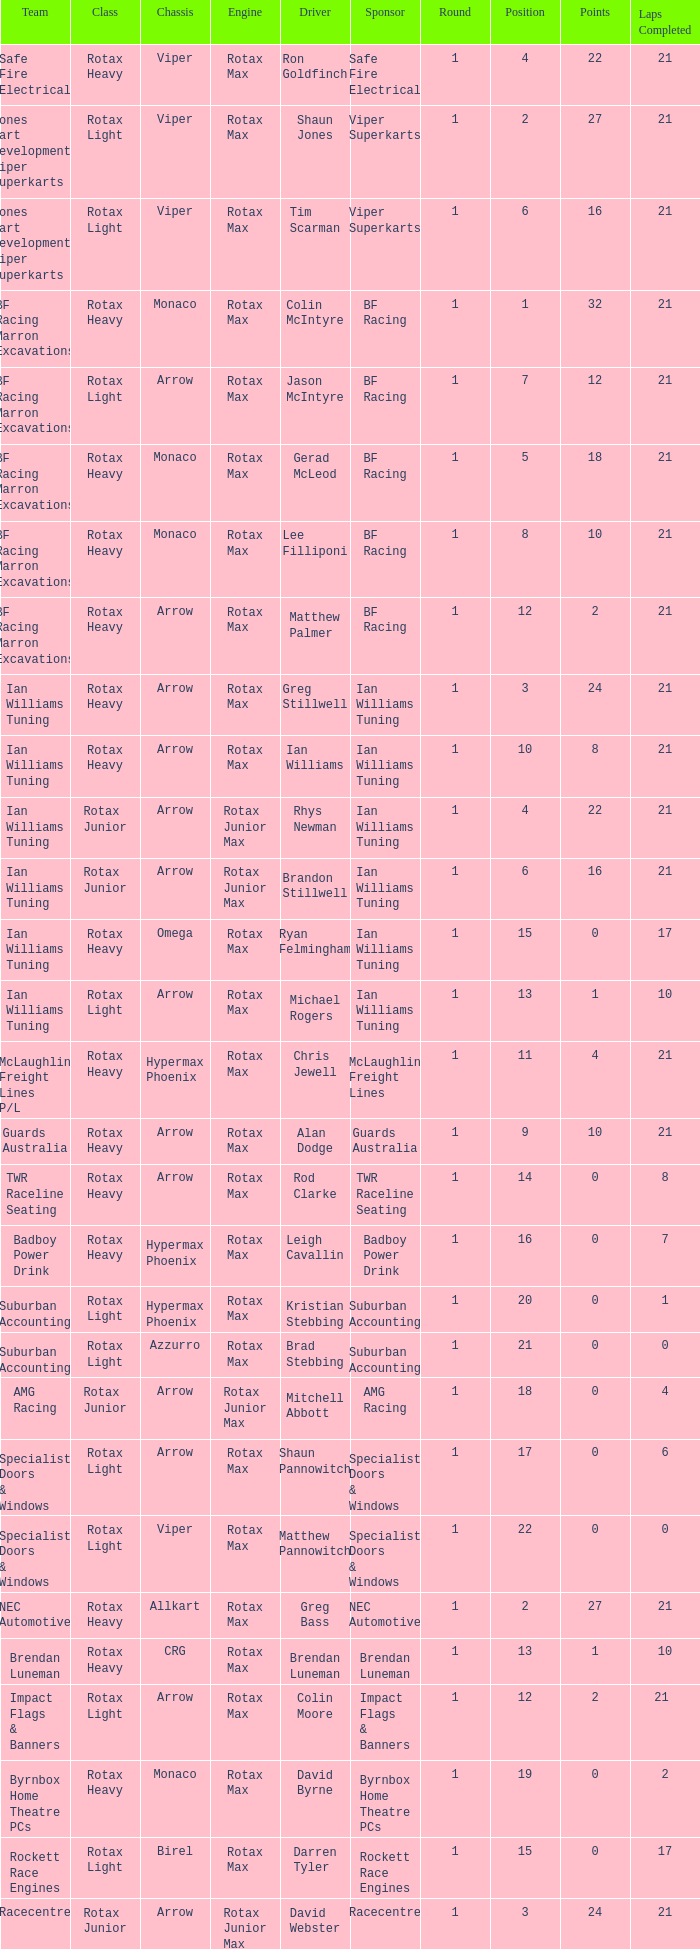What is the name of the team whose class is Rotax Light? Jones Kart Developments Viper Superkarts, Jones Kart Developments Viper Superkarts, BF Racing Marron Excavations, Ian Williams Tuning, Suburban Accounting, Suburban Accounting, Specialist Doors & Windows, Specialist Doors & Windows, Impact Flags & Banners, Rockett Race Engines, Racecentre, Doug Savage. 